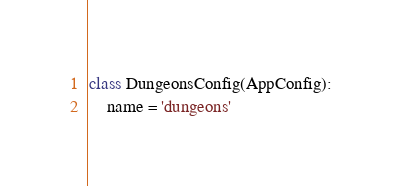Convert code to text. <code><loc_0><loc_0><loc_500><loc_500><_Python_>class DungeonsConfig(AppConfig):
    name = 'dungeons'
</code> 